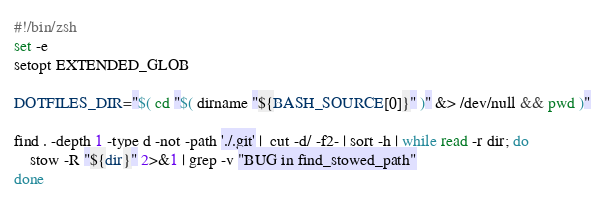<code> <loc_0><loc_0><loc_500><loc_500><_Bash_>#!/bin/zsh
set -e
setopt EXTENDED_GLOB

DOTFILES_DIR="$( cd "$( dirname "${BASH_SOURCE[0]}" )" &> /dev/null && pwd )"

find . -depth 1 -type d -not -path './.git' |  cut -d/ -f2- | sort -h | while read -r dir; do
    stow -R "${dir}" 2>&1 | grep -v "BUG in find_stowed_path"
done
</code> 